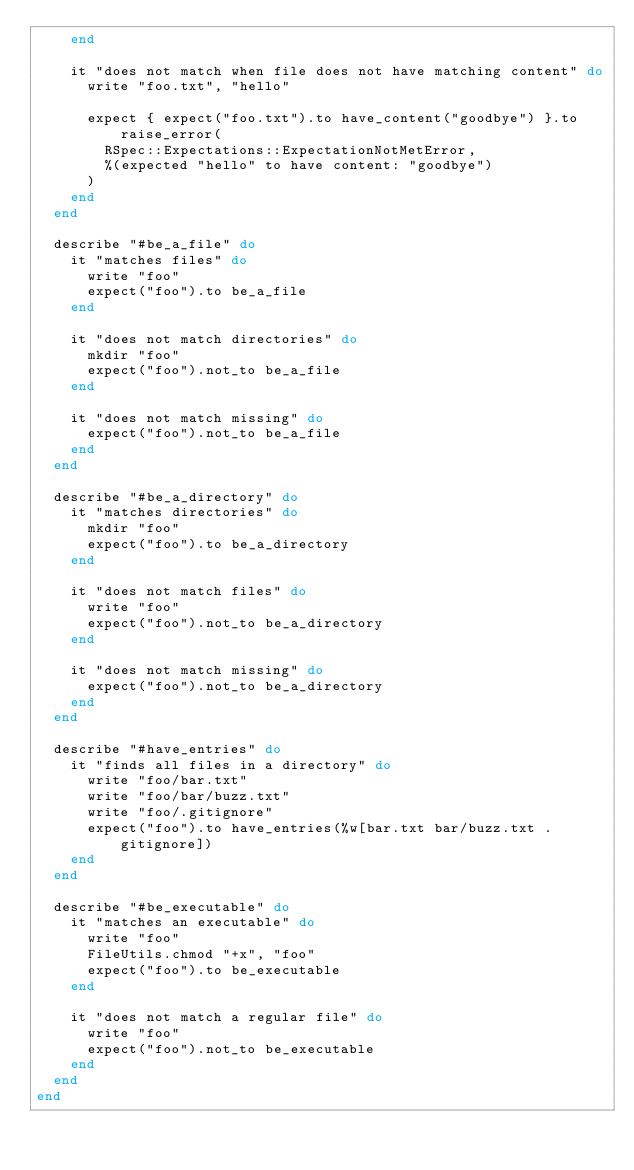<code> <loc_0><loc_0><loc_500><loc_500><_Ruby_>    end

    it "does not match when file does not have matching content" do
      write "foo.txt", "hello"

      expect { expect("foo.txt").to have_content("goodbye") }.to raise_error(
        RSpec::Expectations::ExpectationNotMetError,
        %(expected "hello" to have content: "goodbye")
      )
    end
  end

  describe "#be_a_file" do
    it "matches files" do
      write "foo"
      expect("foo").to be_a_file
    end

    it "does not match directories" do
      mkdir "foo"
      expect("foo").not_to be_a_file
    end

    it "does not match missing" do
      expect("foo").not_to be_a_file
    end
  end

  describe "#be_a_directory" do
    it "matches directories" do
      mkdir "foo"
      expect("foo").to be_a_directory
    end

    it "does not match files" do
      write "foo"
      expect("foo").not_to be_a_directory
    end

    it "does not match missing" do
      expect("foo").not_to be_a_directory
    end
  end

  describe "#have_entries" do
    it "finds all files in a directory" do
      write "foo/bar.txt"
      write "foo/bar/buzz.txt"
      write "foo/.gitignore"
      expect("foo").to have_entries(%w[bar.txt bar/buzz.txt .gitignore])
    end
  end

  describe "#be_executable" do
    it "matches an executable" do
      write "foo"
      FileUtils.chmod "+x", "foo"
      expect("foo").to be_executable
    end

    it "does not match a regular file" do
      write "foo"
      expect("foo").not_to be_executable
    end
  end
end
</code> 